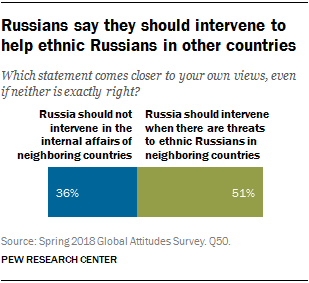Specify some key components in this picture. The two bars are different, with the first bar being 15.. What is the value of the blue bar? It is 36.. 